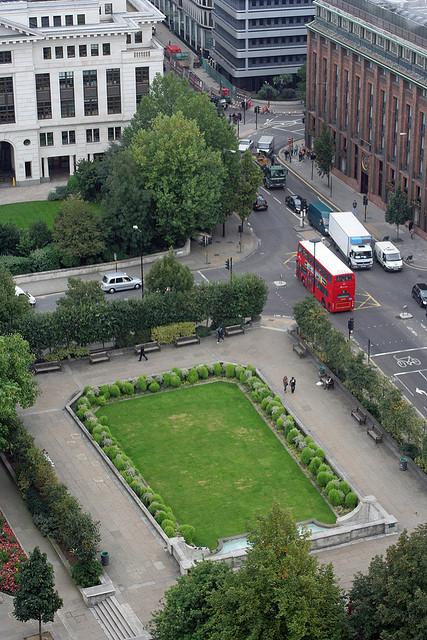What side of the road are cars driving on in the picture?
Concise answer only. Left. What color is the bus on the right?
Be succinct. Red. Is the area at the end of the green rectangle filled with water?
Write a very short answer. Yes. 